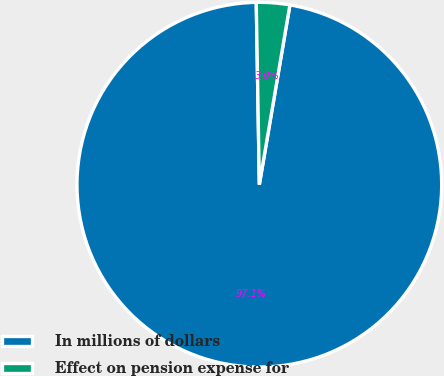Convert chart to OTSL. <chart><loc_0><loc_0><loc_500><loc_500><pie_chart><fcel>In millions of dollars<fcel>Effect on pension expense for<nl><fcel>97.05%<fcel>2.95%<nl></chart> 